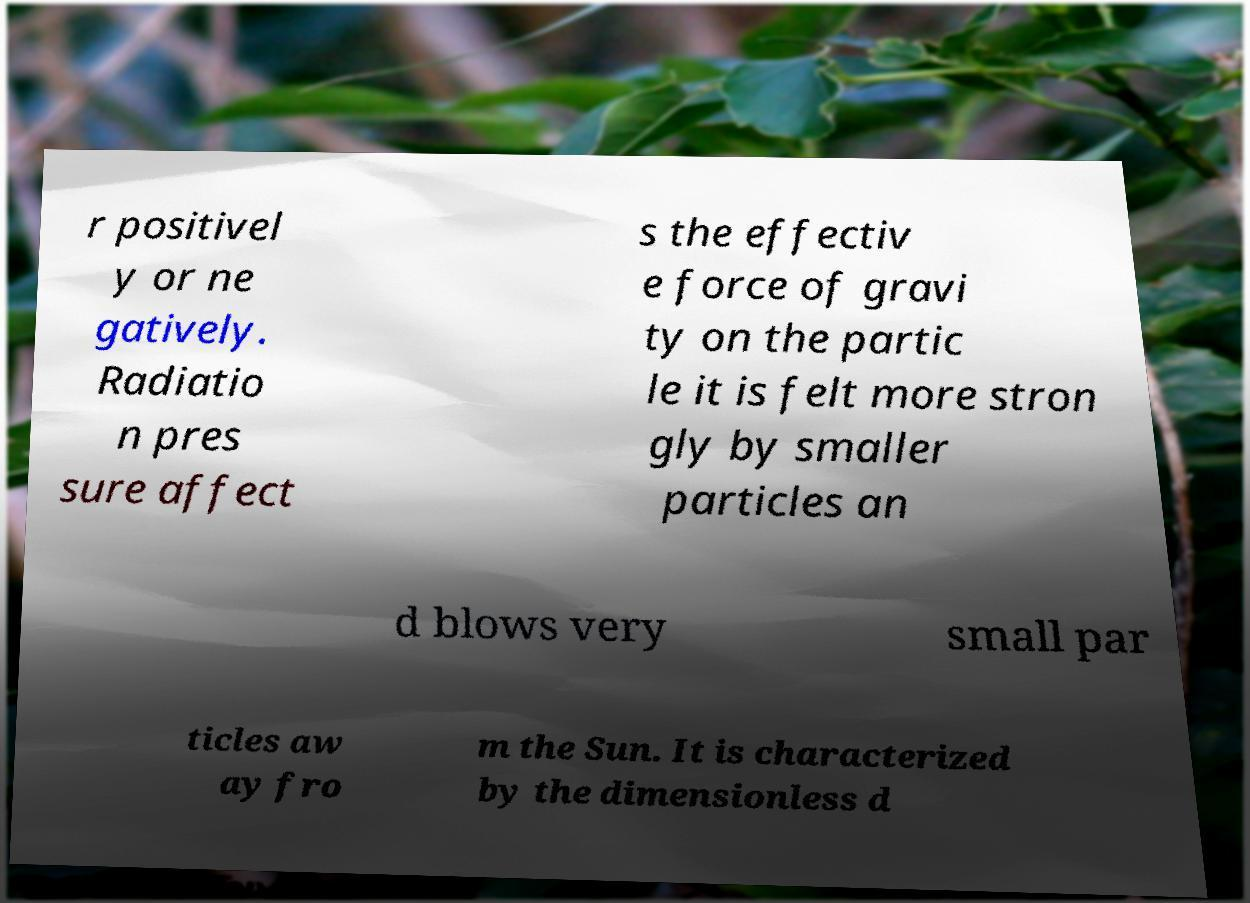What messages or text are displayed in this image? I need them in a readable, typed format. r positivel y or ne gatively. Radiatio n pres sure affect s the effectiv e force of gravi ty on the partic le it is felt more stron gly by smaller particles an d blows very small par ticles aw ay fro m the Sun. It is characterized by the dimensionless d 